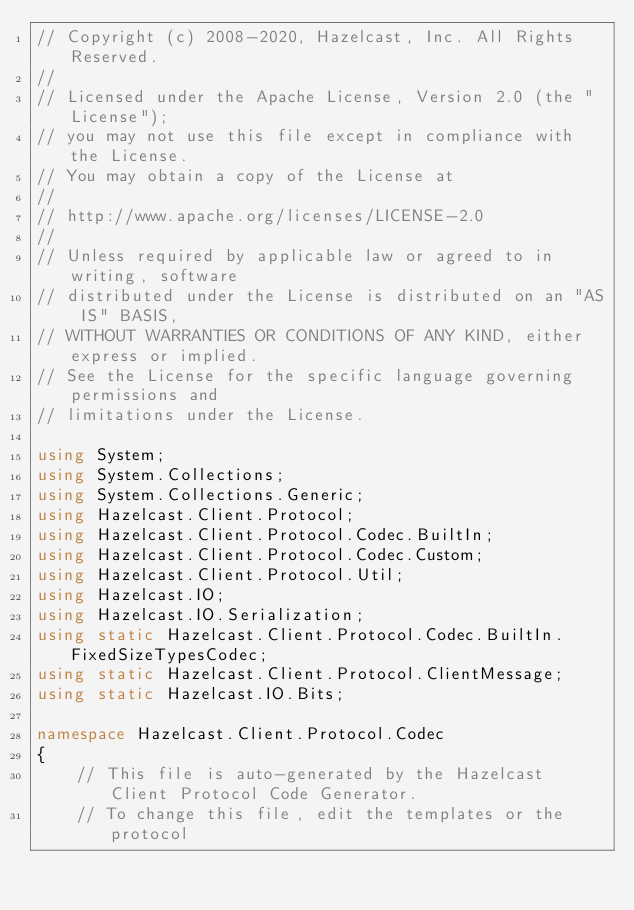<code> <loc_0><loc_0><loc_500><loc_500><_C#_>// Copyright (c) 2008-2020, Hazelcast, Inc. All Rights Reserved.
//
// Licensed under the Apache License, Version 2.0 (the "License");
// you may not use this file except in compliance with the License.
// You may obtain a copy of the License at
//
// http://www.apache.org/licenses/LICENSE-2.0
//
// Unless required by applicable law or agreed to in writing, software
// distributed under the License is distributed on an "AS IS" BASIS,
// WITHOUT WARRANTIES OR CONDITIONS OF ANY KIND, either express or implied.
// See the License for the specific language governing permissions and
// limitations under the License.

using System;
using System.Collections;
using System.Collections.Generic;
using Hazelcast.Client.Protocol;
using Hazelcast.Client.Protocol.Codec.BuiltIn;
using Hazelcast.Client.Protocol.Codec.Custom;
using Hazelcast.Client.Protocol.Util;
using Hazelcast.IO;
using Hazelcast.IO.Serialization;
using static Hazelcast.Client.Protocol.Codec.BuiltIn.FixedSizeTypesCodec;
using static Hazelcast.Client.Protocol.ClientMessage;
using static Hazelcast.IO.Bits;

namespace Hazelcast.Client.Protocol.Codec
{
    // This file is auto-generated by the Hazelcast Client Protocol Code Generator.
    // To change this file, edit the templates or the protocol</code> 